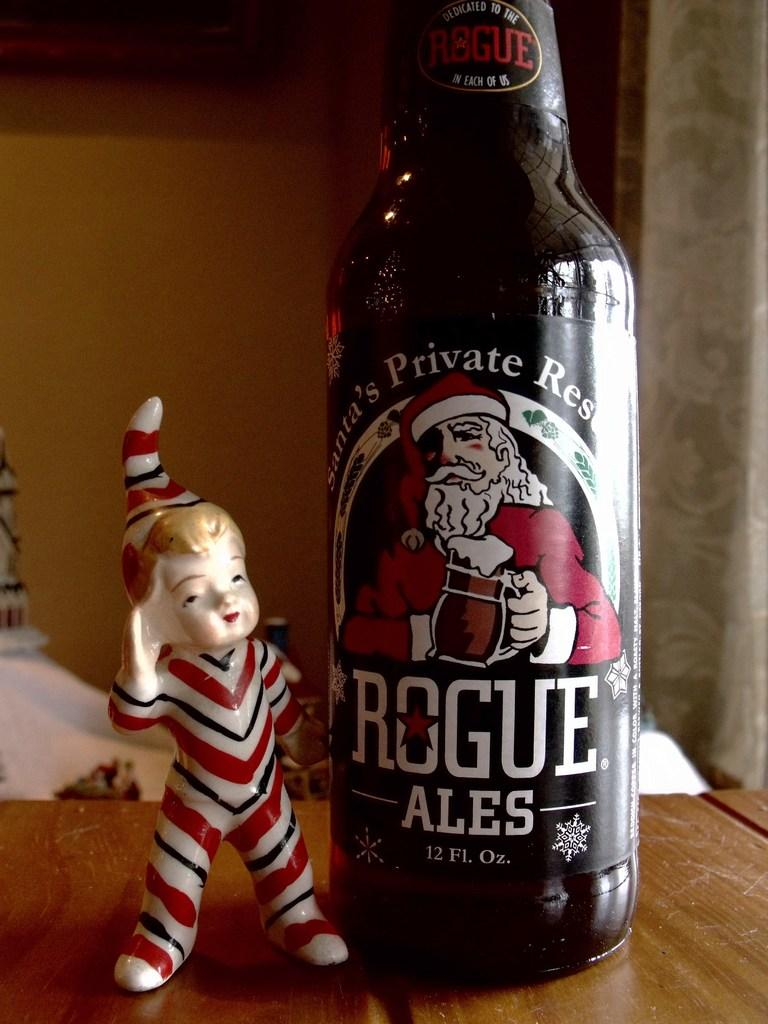<image>
Describe the image concisely. A bottle of Santa's Private Reserve Ale next to a elf statue. 